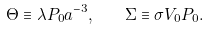Convert formula to latex. <formula><loc_0><loc_0><loc_500><loc_500>\Theta \equiv \lambda P _ { 0 } a ^ { - 3 } , \quad \Sigma \equiv \sigma V _ { 0 } P _ { 0 } .</formula> 